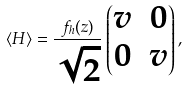Convert formula to latex. <formula><loc_0><loc_0><loc_500><loc_500>\langle H \rangle = \frac { f _ { h } ( z ) } { \sqrt { 2 } } \begin{pmatrix} v & 0 \\ 0 & v \end{pmatrix} ,</formula> 